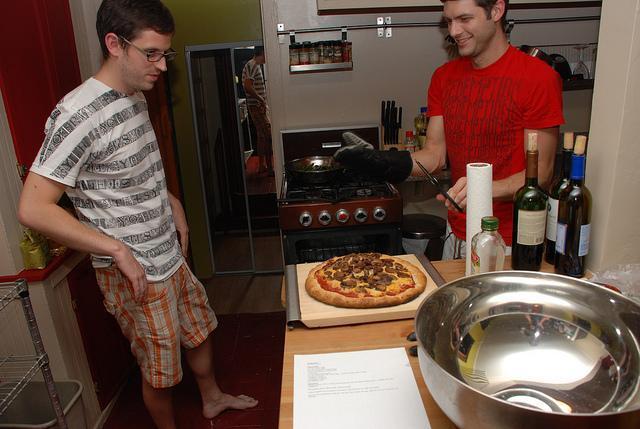Does the caption "The pizza is behind the bowl." correctly depict the image?
Answer yes or no. Yes. 